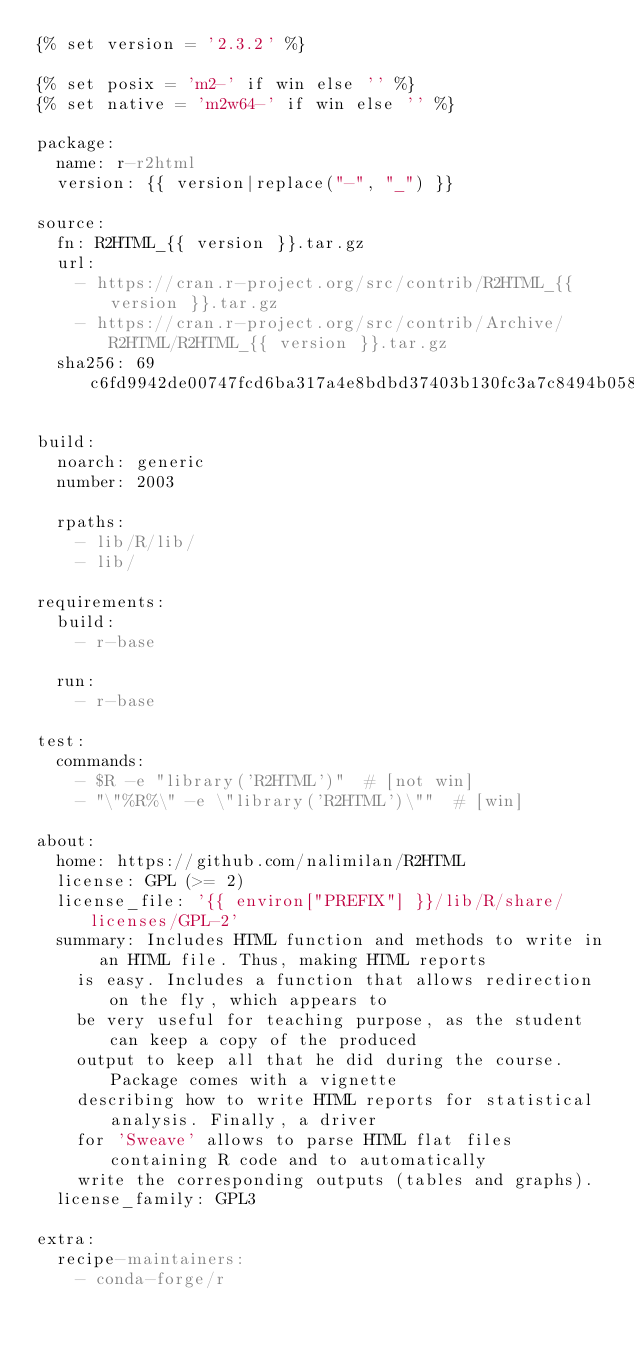<code> <loc_0><loc_0><loc_500><loc_500><_YAML_>{% set version = '2.3.2' %}

{% set posix = 'm2-' if win else '' %}
{% set native = 'm2w64-' if win else '' %}

package:
  name: r-r2html
  version: {{ version|replace("-", "_") }}

source:
  fn: R2HTML_{{ version }}.tar.gz
  url:
    - https://cran.r-project.org/src/contrib/R2HTML_{{ version }}.tar.gz
    - https://cran.r-project.org/src/contrib/Archive/R2HTML/R2HTML_{{ version }}.tar.gz
  sha256: 69c6fd9942de00747fcd6ba317a4e8bdbd37403b130fc3a7c8494b058fb77d02

build:
  noarch: generic
  number: 2003

  rpaths:
    - lib/R/lib/
    - lib/

requirements:
  build:
    - r-base

  run:
    - r-base

test:
  commands:
    - $R -e "library('R2HTML')"  # [not win]
    - "\"%R%\" -e \"library('R2HTML')\""  # [win]

about:
  home: https://github.com/nalimilan/R2HTML
  license: GPL (>= 2)
  license_file: '{{ environ["PREFIX"] }}/lib/R/share/licenses/GPL-2'
  summary: Includes HTML function and methods to write in an HTML file. Thus, making HTML reports
    is easy. Includes a function that allows redirection on the fly, which appears to
    be very useful for teaching purpose, as the student can keep a copy of the produced
    output to keep all that he did during the course. Package comes with a vignette
    describing how to write HTML reports for statistical analysis. Finally, a driver
    for 'Sweave' allows to parse HTML flat files containing R code and to automatically
    write the corresponding outputs (tables and graphs).
  license_family: GPL3

extra:
  recipe-maintainers:
    - conda-forge/r
</code> 